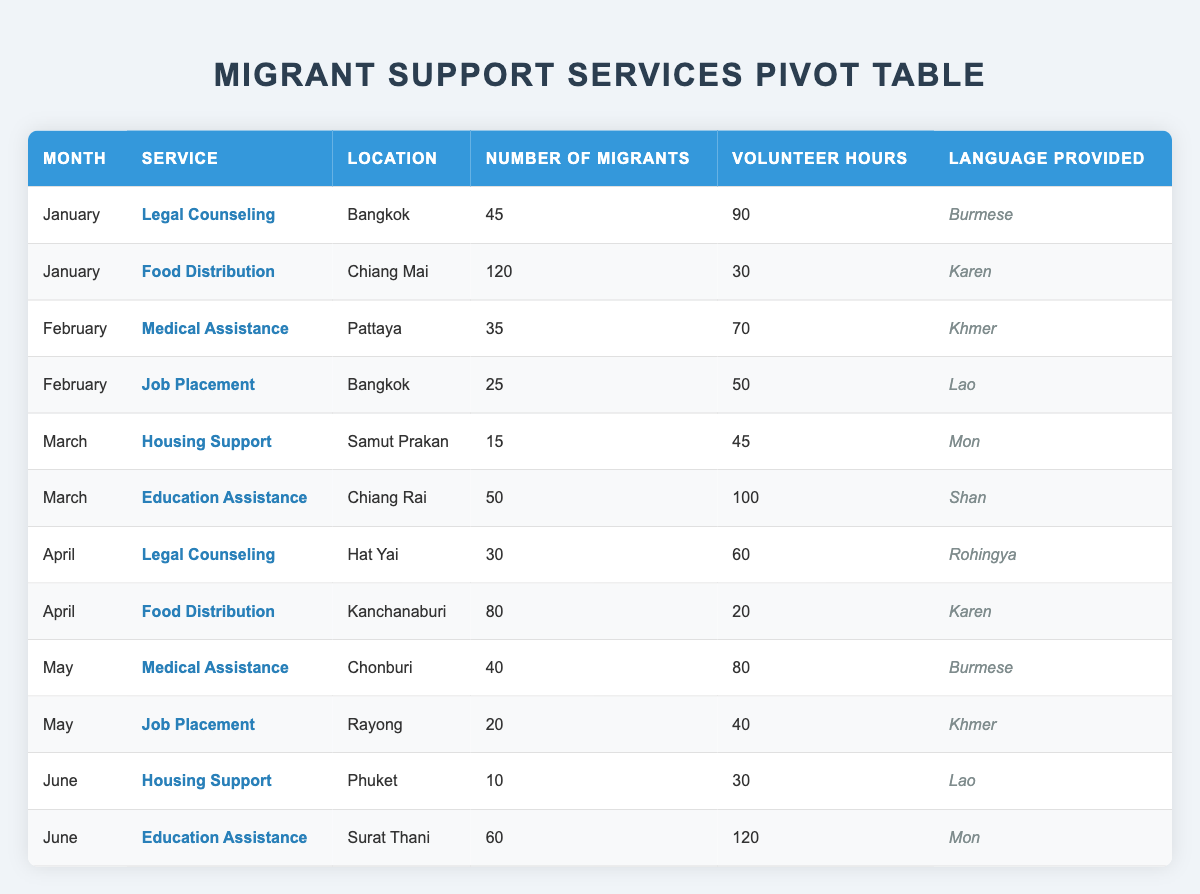What is the most common service provided in January? In January, there are two services listed: Legal Counseling and Food Distribution. The volume of migrants for Legal Counseling is 45, and for Food Distribution, it is 120. Therefore, Food Distribution is the most common service provided.
Answer: Food Distribution How many total volunteer hours were contributed for services in March? In March, there are two services: Housing Support (45 hours) and Education Assistance (100 hours). Adding these gives a total of 145 volunteer hours for that month.
Answer: 145 Did any service provide support to more than 100 migrants in a single month? Reviewing the table shows that in January, Food Distribution supported 120 migrants, which is greater than 100. Thus, the answer is yes.
Answer: Yes Which location provided Education Assistance, and how many migrants were served in June? The table indicates that Education Assistance was provided in Surat Thani in June, serving 60 migrants.
Answer: Surat Thani, 60 What is the sum of all the Number of Migrants supported from January to April? Adding the Number of Migrants: January (165 from 45 and 120), February (60 from 35 and 25), March (65 from 15 and 50), and April (110 from 30 and 80). The total is: 165 + 60 + 65 + 110 = 400.
Answer: 400 Is there a service in April where volunteers contributed fewer than 30 hours? In April, the Food Distribution service in Kanchanaburi had only 20 volunteer hours, indicating that there is indeed a service with fewer than 30 hours.
Answer: Yes What was the average number of migrants served per service in May? There are two services in May (Medical Assistance with 40 migrants and Job Placement with 20 migrants). Adding these (40 + 20 = 60) and dividing by the number of services (2) gives an average of 30 migrants served per service.
Answer: 30 Which language was predominantly provided for Medical Assistance in February? The table indicates that for Medical Assistance in February, the language provided was Khmer.
Answer: Khmer How many migrant support services were provided in April, and which one supported the fewest migrants? In April, there were two services: Legal Counseling (30 migrants) and Food Distribution (80 migrants). Legal Counseling had fewer migrants. The total number of services is 2.
Answer: 2, Legal Counseling 